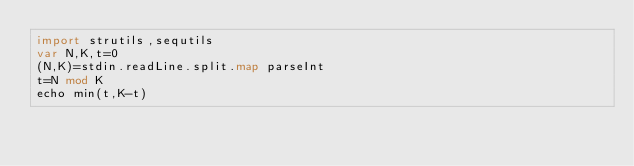Convert code to text. <code><loc_0><loc_0><loc_500><loc_500><_Nim_>import strutils,sequtils
var N,K,t=0
(N,K)=stdin.readLine.split.map parseInt
t=N mod K
echo min(t,K-t)</code> 